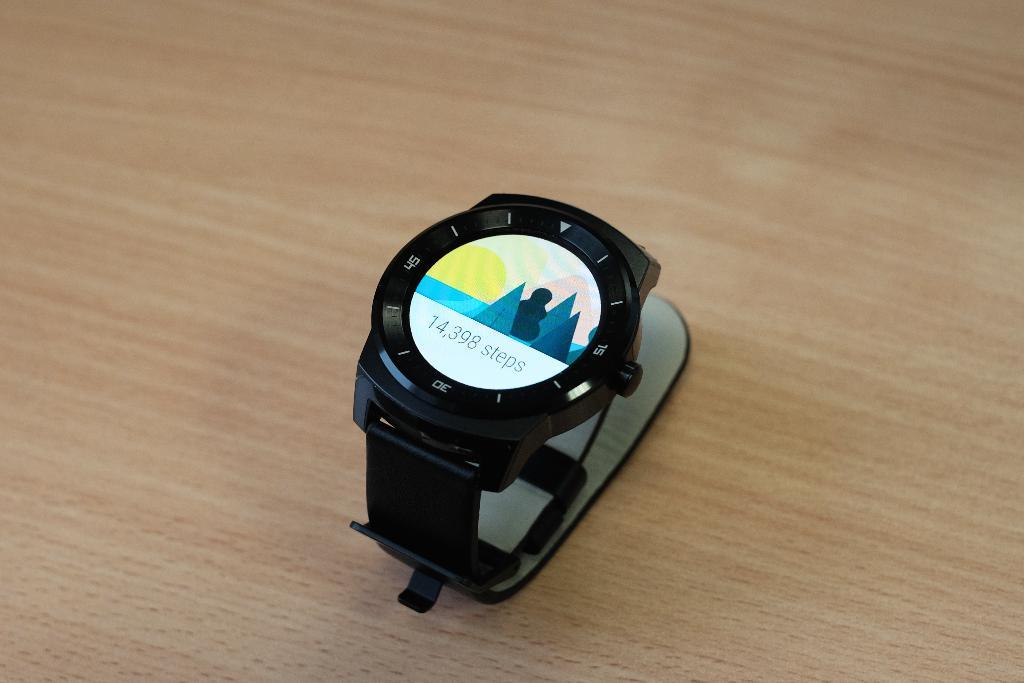How many steps were taken according to the watch?
Your answer should be compact. 14,398. 